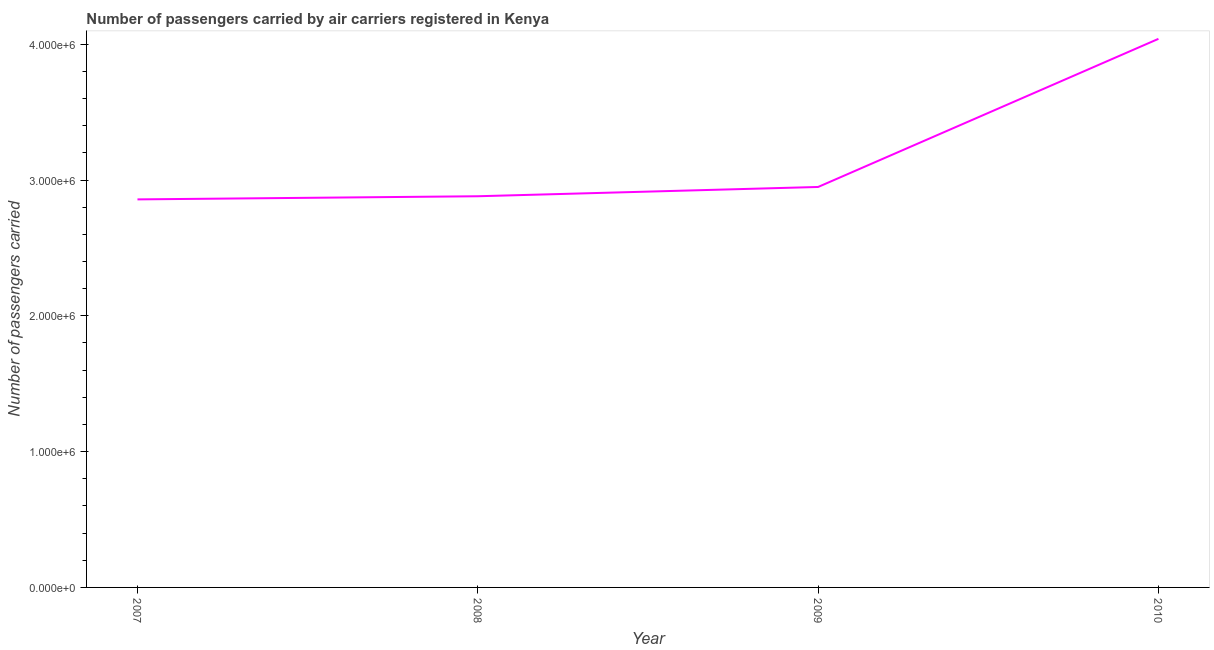What is the number of passengers carried in 2010?
Ensure brevity in your answer.  4.04e+06. Across all years, what is the maximum number of passengers carried?
Your response must be concise. 4.04e+06. Across all years, what is the minimum number of passengers carried?
Ensure brevity in your answer.  2.86e+06. In which year was the number of passengers carried maximum?
Your response must be concise. 2010. What is the sum of the number of passengers carried?
Keep it short and to the point. 1.27e+07. What is the difference between the number of passengers carried in 2009 and 2010?
Your answer should be compact. -1.09e+06. What is the average number of passengers carried per year?
Provide a short and direct response. 3.18e+06. What is the median number of passengers carried?
Give a very brief answer. 2.91e+06. In how many years, is the number of passengers carried greater than 1800000 ?
Keep it short and to the point. 4. Do a majority of the years between 2009 and 2010 (inclusive) have number of passengers carried greater than 1800000 ?
Your answer should be very brief. Yes. What is the ratio of the number of passengers carried in 2008 to that in 2009?
Provide a short and direct response. 0.98. Is the number of passengers carried in 2008 less than that in 2010?
Your answer should be compact. Yes. What is the difference between the highest and the second highest number of passengers carried?
Offer a terse response. 1.09e+06. Is the sum of the number of passengers carried in 2007 and 2010 greater than the maximum number of passengers carried across all years?
Keep it short and to the point. Yes. What is the difference between the highest and the lowest number of passengers carried?
Your response must be concise. 1.18e+06. How many lines are there?
Give a very brief answer. 1. How many years are there in the graph?
Offer a terse response. 4. Does the graph contain any zero values?
Offer a very short reply. No. What is the title of the graph?
Offer a very short reply. Number of passengers carried by air carriers registered in Kenya. What is the label or title of the X-axis?
Keep it short and to the point. Year. What is the label or title of the Y-axis?
Provide a succinct answer. Number of passengers carried. What is the Number of passengers carried of 2007?
Provide a succinct answer. 2.86e+06. What is the Number of passengers carried in 2008?
Provide a succinct answer. 2.88e+06. What is the Number of passengers carried in 2009?
Make the answer very short. 2.95e+06. What is the Number of passengers carried in 2010?
Provide a short and direct response. 4.04e+06. What is the difference between the Number of passengers carried in 2007 and 2008?
Provide a succinct answer. -2.31e+04. What is the difference between the Number of passengers carried in 2007 and 2009?
Your response must be concise. -9.15e+04. What is the difference between the Number of passengers carried in 2007 and 2010?
Offer a very short reply. -1.18e+06. What is the difference between the Number of passengers carried in 2008 and 2009?
Provide a short and direct response. -6.84e+04. What is the difference between the Number of passengers carried in 2008 and 2010?
Your response must be concise. -1.16e+06. What is the difference between the Number of passengers carried in 2009 and 2010?
Provide a succinct answer. -1.09e+06. What is the ratio of the Number of passengers carried in 2007 to that in 2008?
Keep it short and to the point. 0.99. What is the ratio of the Number of passengers carried in 2007 to that in 2010?
Your answer should be compact. 0.71. What is the ratio of the Number of passengers carried in 2008 to that in 2009?
Your answer should be compact. 0.98. What is the ratio of the Number of passengers carried in 2008 to that in 2010?
Ensure brevity in your answer.  0.71. What is the ratio of the Number of passengers carried in 2009 to that in 2010?
Provide a short and direct response. 0.73. 